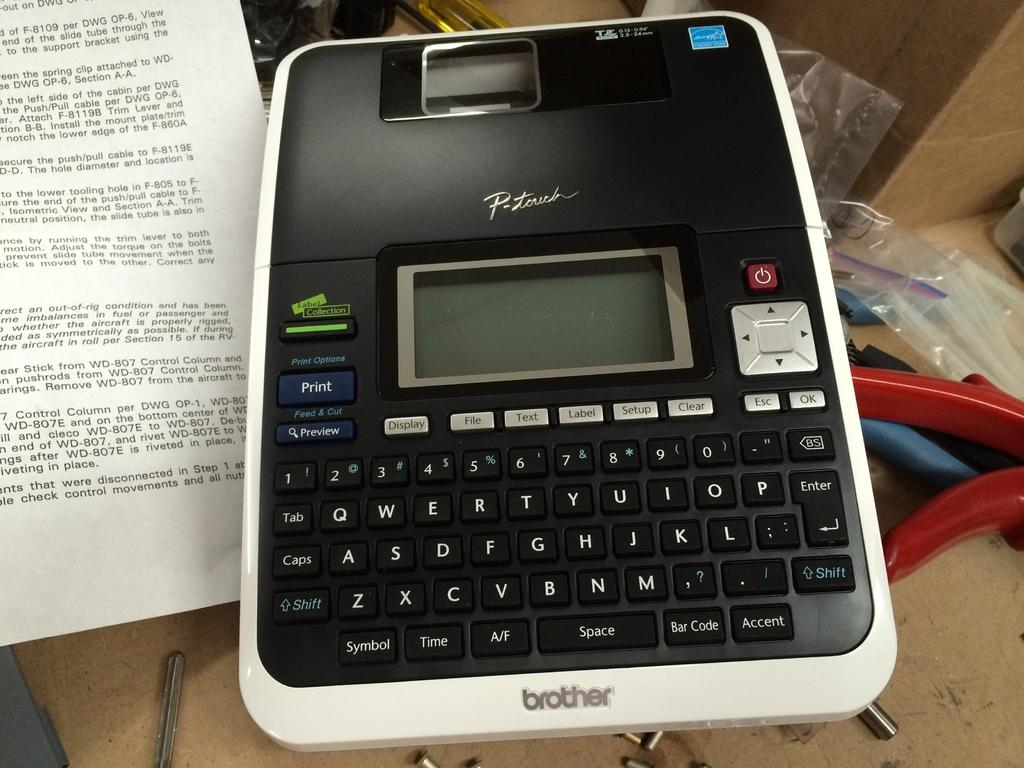Provide a one-sentence caption for the provided image. the word brother that is on a calculator. 